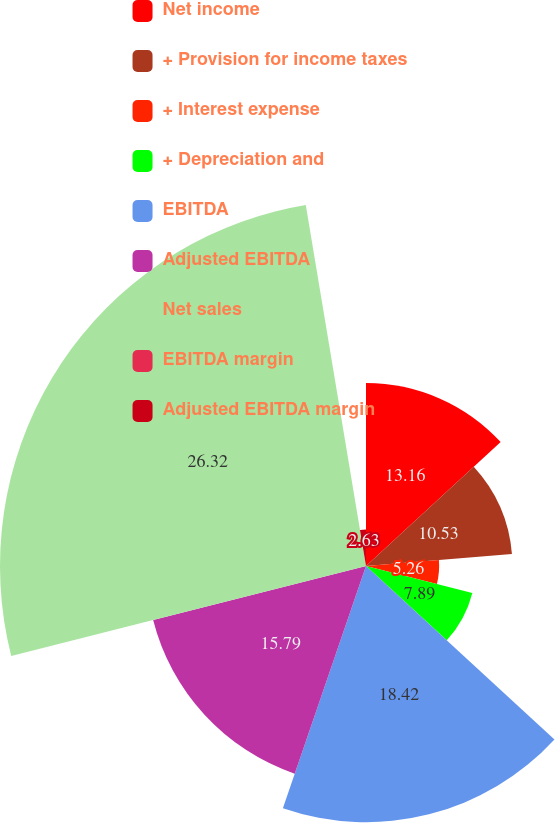Convert chart. <chart><loc_0><loc_0><loc_500><loc_500><pie_chart><fcel>Net income<fcel>+ Provision for income taxes<fcel>+ Interest expense<fcel>+ Depreciation and<fcel>EBITDA<fcel>Adjusted EBITDA<fcel>Net sales<fcel>EBITDA margin<fcel>Adjusted EBITDA margin<nl><fcel>13.16%<fcel>10.53%<fcel>5.26%<fcel>7.89%<fcel>18.42%<fcel>15.79%<fcel>26.32%<fcel>0.0%<fcel>2.63%<nl></chart> 